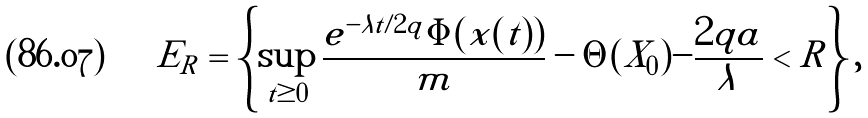Convert formula to latex. <formula><loc_0><loc_0><loc_500><loc_500>E _ { R } = \left \{ \sup _ { t \geq 0 } \frac { e ^ { - \lambda t / 2 q } \Phi ( x ( t ) ) } { m } - \Theta ( X _ { 0 } ) - \frac { 2 q a } { \lambda } < R \right \} ,</formula> 